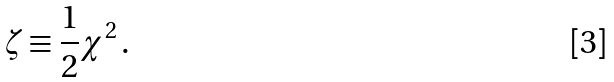Convert formula to latex. <formula><loc_0><loc_0><loc_500><loc_500>\zeta \equiv \frac { 1 } { 2 } \chi ^ { 2 } \, .</formula> 